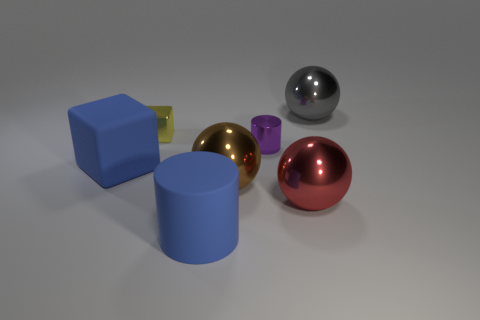Subtract 1 spheres. How many spheres are left? 2 Add 2 brown rubber spheres. How many objects exist? 9 Subtract all cylinders. How many objects are left? 5 Add 6 cylinders. How many cylinders exist? 8 Subtract 0 red cylinders. How many objects are left? 7 Subtract all metallic spheres. Subtract all yellow cylinders. How many objects are left? 4 Add 6 purple metal cylinders. How many purple metal cylinders are left? 7 